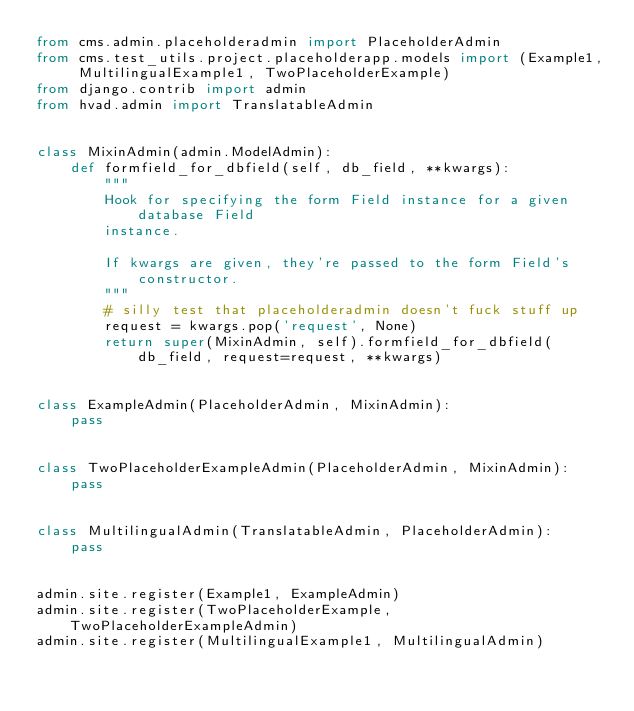<code> <loc_0><loc_0><loc_500><loc_500><_Python_>from cms.admin.placeholderadmin import PlaceholderAdmin
from cms.test_utils.project.placeholderapp.models import (Example1, MultilingualExample1, TwoPlaceholderExample)
from django.contrib import admin
from hvad.admin import TranslatableAdmin


class MixinAdmin(admin.ModelAdmin):
    def formfield_for_dbfield(self, db_field, **kwargs):
        """
        Hook for specifying the form Field instance for a given database Field
        instance.

        If kwargs are given, they're passed to the form Field's constructor.
        """
        # silly test that placeholderadmin doesn't fuck stuff up
        request = kwargs.pop('request', None)
        return super(MixinAdmin, self).formfield_for_dbfield(db_field, request=request, **kwargs)


class ExampleAdmin(PlaceholderAdmin, MixinAdmin):
    pass


class TwoPlaceholderExampleAdmin(PlaceholderAdmin, MixinAdmin):
    pass


class MultilingualAdmin(TranslatableAdmin, PlaceholderAdmin):
    pass


admin.site.register(Example1, ExampleAdmin)
admin.site.register(TwoPlaceholderExample, TwoPlaceholderExampleAdmin)
admin.site.register(MultilingualExample1, MultilingualAdmin)
</code> 